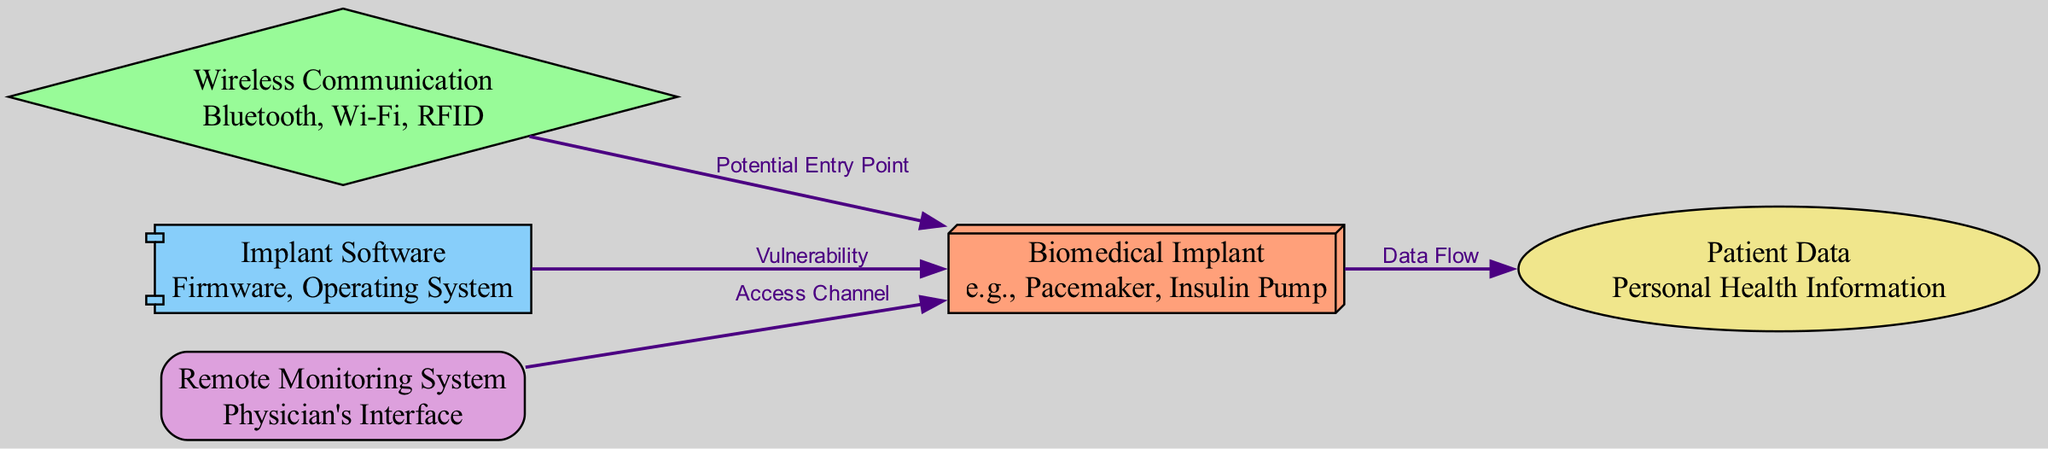What is the main subject of the diagram? The diagram primarily illustrates the vulnerabilities of biomedical implants to cyberattacks, including various nodes connected by potential entry points and data flows.
Answer: Biomedical Implant How many nodes are present in the diagram? By counting the individual entities listed as nodes, there are five distinct nodes in the diagram.
Answer: Five What type of communication is a potential entry point for hackers? The edge labeled "Potential Entry Point" connects the "Wireless Communication" node to the "Biomedical Implant" node, indicating that wireless communication is vulnerable.
Answer: Wireless Communication Which node represents patient health information? The node labeled "Patient Data" specifically describes the personal health information of the patient, making it the relevant node.
Answer: Patient Data What is the relationship between the “Implant Software” and “Biomedical Implant”? The diagram shows a direct edge labeled "Vulnerability" from the "Implant Software" node to the "Biomedical Implant" node, indicating a vulnerability from the implant's software to the implant itself.
Answer: Vulnerability How does patient data flow in the diagram? The flow of the diagram indicates that data moves from the "Biomedical Implant" node to the "Patient Data" node, illustrating how data is transferred to access personal health information.
Answer: Data Flow What node serves as an access channel for the biomedical implant? The diagram includes an edge labeled "Access Channel" that connects the "Remote Monitoring System" node to the "Biomedical Implant" node, indicating that remote monitoring is an access channel.
Answer: Remote Monitoring System What type of software is indicated as a vulnerability? The edge pointing from “Implant Software” to “Biomedical Implant” labeled with "Vulnerability" suggests that both firmware and operating systems can present vulnerabilities.
Answer: Implant Software 